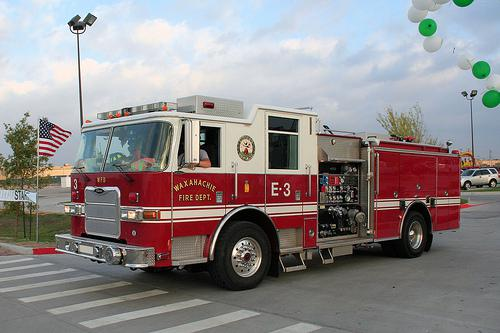Question: what country's flag is flying?
Choices:
A. Switzerland.
B. Germany.
C. England.
D. USA.
Answer with the letter. Answer: D Question: what kind of truck is in the photo?
Choices:
A. Ambulance.
B. Mail truck.
C. Fire Truck.
D. Garbage truck.
Answer with the letter. Answer: C Question: how many green balloons are visible?
Choices:
A. 1.
B. 4.
C. 2.
D. 3.
Answer with the letter. Answer: B Question: where are the balloons?
Choices:
A. On the table.
B. In the child's hand.
C. On the floor.
D. In the air.
Answer with the letter. Answer: D Question: what arm does the driver have out the window?
Choices:
A. Left.
B. None.
C. Right.
D. Left and right.
Answer with the letter. Answer: A Question: what color are the lines on the pavement?
Choices:
A. Yellow.
B. Green.
C. Red.
D. White.
Answer with the letter. Answer: D 